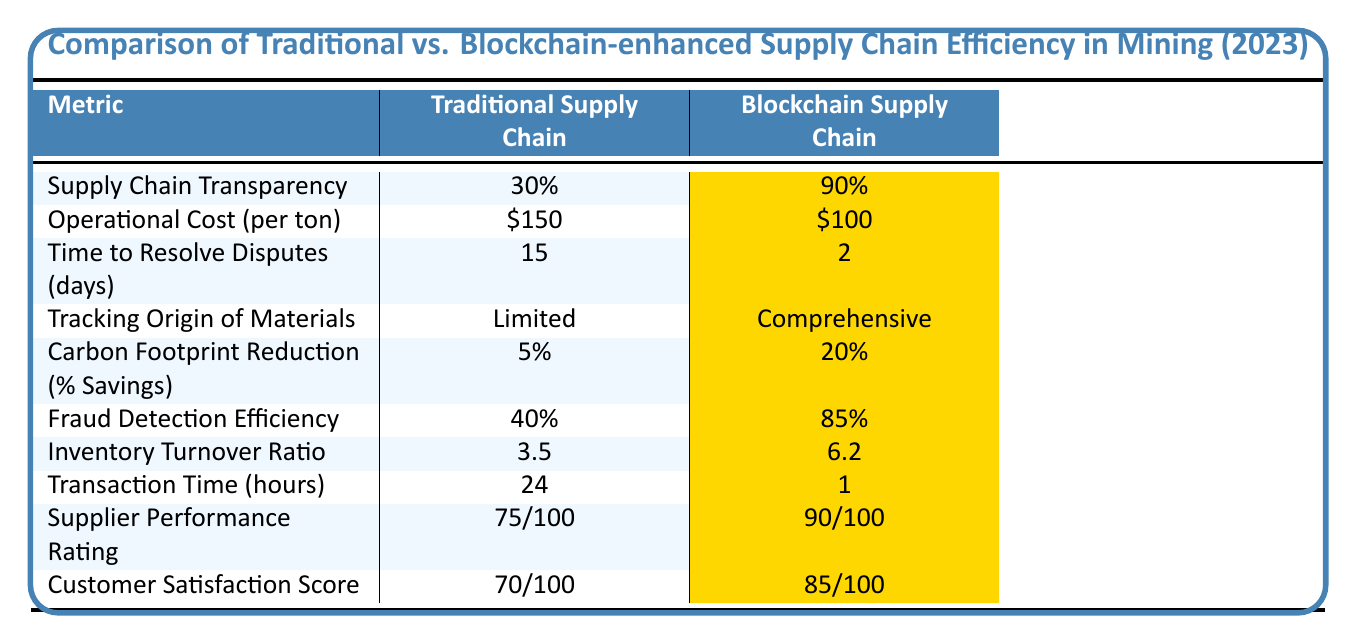What is the percentage of supply chain transparency in the blockchain supply chain? The table indicates that the blockchain supply chain has a supply chain transparency of 90%.
Answer: 90% How much does it cost operationally per ton in the traditional supply chain? According to the table, the operational cost per ton in the traditional supply chain is $150.
Answer: $150 How long does it take, on average, to resolve disputes in the blockchain supply chain? The table shows that disputes in the blockchain supply chain take an average of 2 days to resolve.
Answer: 2 days What is the carbon footprint reduction percentage for traditional supply chains? From the table, the traditional supply chain has a carbon footprint reduction of 5%.
Answer: 5% Is the fraud detection efficiency higher in the blockchain supply chain compared to the traditional one? Yes, the blockchain supply chain has a fraud detection efficiency of 85%, which is higher than the traditional supply chain's 40%.
Answer: Yes What is the difference in supplier performance rating between traditional and blockchain supply chains? The traditional supply chain has a rating of 75/100, while the blockchain supply chain has 90/100. The difference is 90 - 75 = 15.
Answer: 15 What is the average inventory turnover ratio for both types of supply chains? The average is calculated by adding both inventory turnover ratios (3.5 + 6.2) and dividing by 2. The average is (3.5 + 6.2)/2 = 4.85.
Answer: 4.85 Does the blockchain supply chain have a lower transaction time than the traditional supply chain? Yes, the blockchain supply chain has a transaction time of 1 hour, which is significantly lower than the traditional supply chain's 24 hours.
Answer: Yes What is the improvement in customer satisfaction score when moving from a traditional to a blockchain supply chain? The traditional customer satisfaction score is 70/100 and the blockchain score is 85/100. The improvement is 85 - 70 = 15.
Answer: 15 Which supply chain has a better tracking origin of materials capability? The blockchain supply chain has a comprehensive tracking capability, while the traditional one is limited. Therefore, the blockchain supply chain is superior.
Answer: Blockchain supply chain 